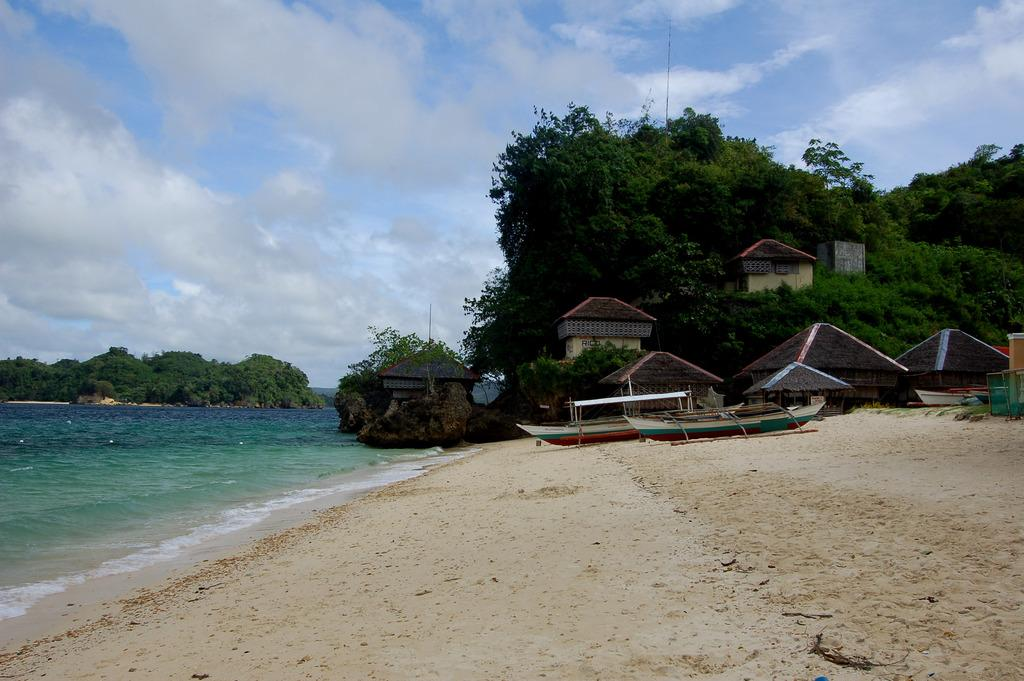What is located on the left side of the image? There is water and trees on the left side of the image. What can be seen in the center of the image? There are huts and trees in the center of the image. What is the condition of the sky in the image? The sky is cloudy in the image. Can you see a thumb in the image? There is no thumb present in the image. How many bees are flying around the huts in the image? There are no bees visible in the image. 